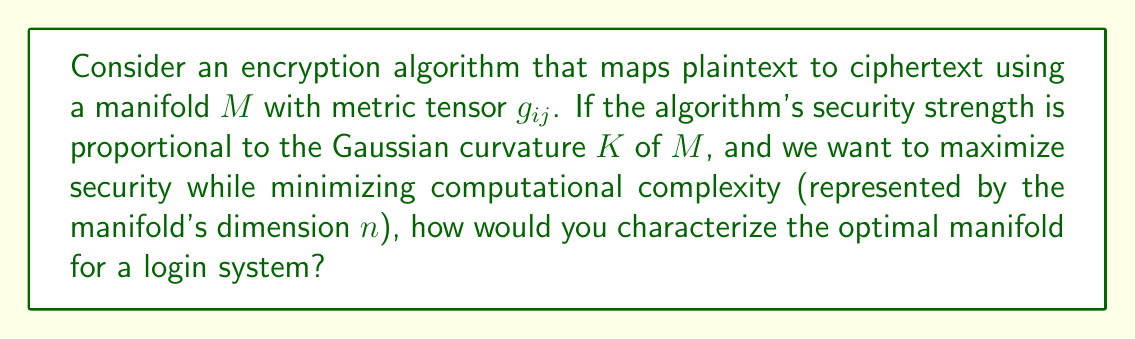Show me your answer to this math problem. 1. The Gaussian curvature $K$ of a manifold is given by:

   $$K = \frac{R}{2}$$

   where $R$ is the scalar curvature.

2. For an $n$-dimensional manifold, the scalar curvature is:

   $$R = g^{ij}R_{ij}$$

   where $g^{ij}$ is the inverse metric tensor and $R_{ij}$ is the Ricci tensor.

3. For a maximally symmetric space, which would provide uniform security across the manifold:

   $$R_{ij} = \frac{R}{n}g_{ij}$$

4. Substituting this into the scalar curvature equation:

   $$R = g^{ij}\frac{R}{n}g_{ij} = \frac{R}{n}g^{ij}g_{ij} = \frac{R}{n}n = R$$

5. This implies that for a maximally symmetric space:

   $$K = \frac{R}{2} = \frac{n(n-1)}{2l^2}$$

   where $l$ is the curvature radius.

6. To maximize security (K) while minimizing complexity (n), we want to maximize the ratio:

   $$\frac{K}{n} = \frac{n-1}{2l^2}$$

7. This ratio approaches its maximum as $n$ approaches 2 and $l$ approaches its minimum possible value.

8. Therefore, the optimal manifold would be a 2-dimensional manifold (surface) with constant positive curvature and the smallest possible curvature radius.
Answer: 2-dimensional sphere with minimum radius 